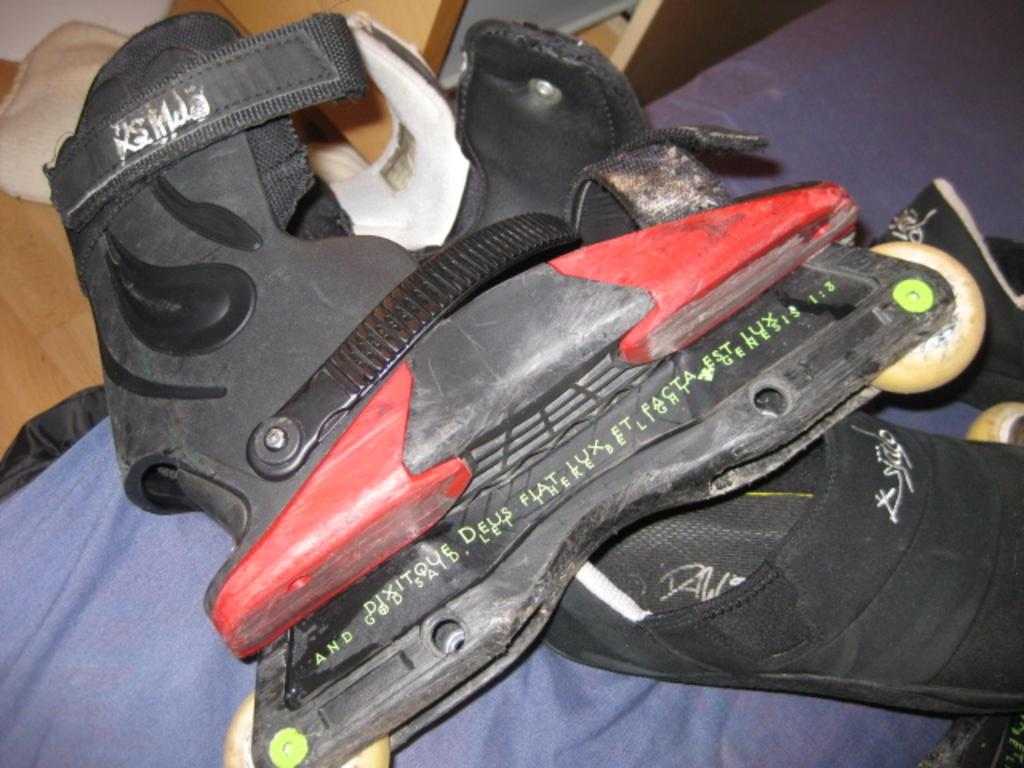What type of shoes are in the middle of the image? There is a pair of skating shoes in the middle of the image. What type of fuel is being used by the government in the image? There is no reference to fuel or the government in the image; it only features a pair of skating shoes. 